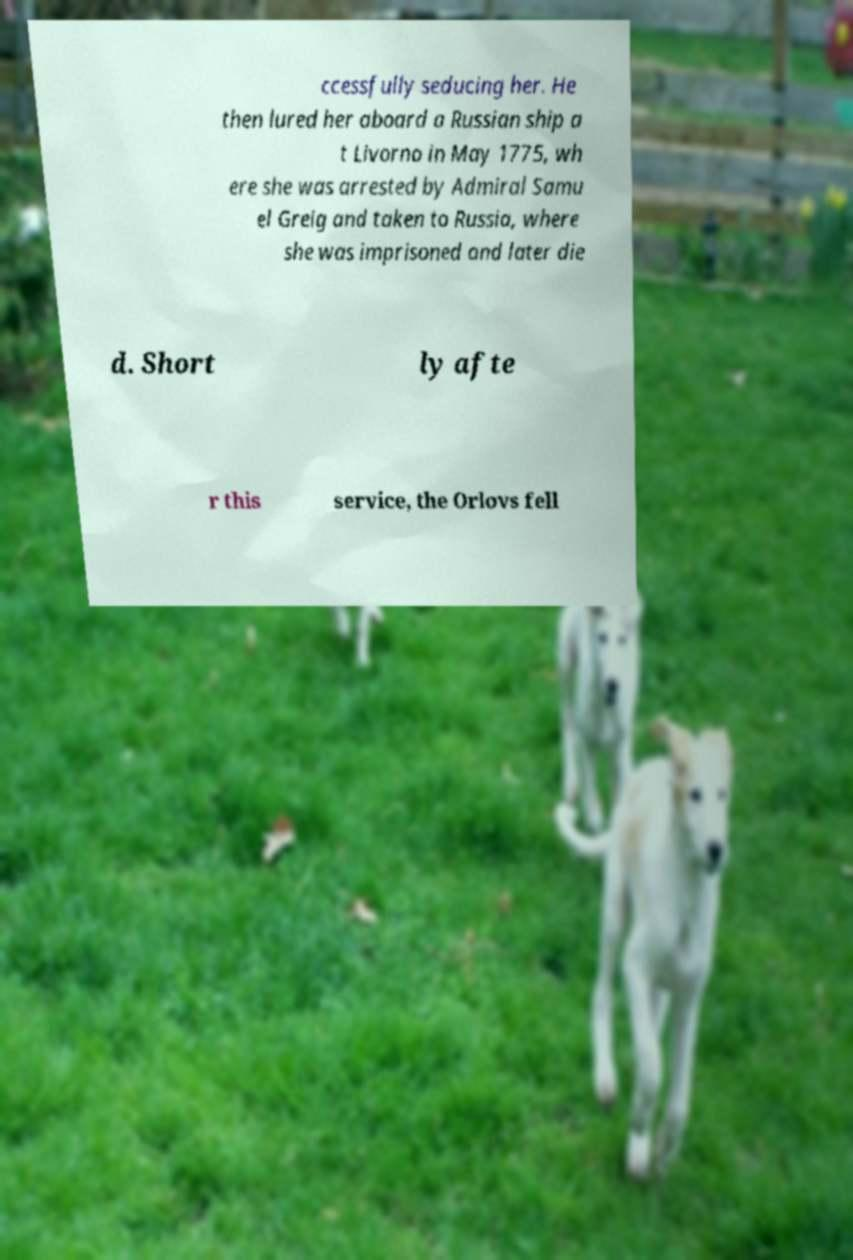Could you extract and type out the text from this image? ccessfully seducing her. He then lured her aboard a Russian ship a t Livorno in May 1775, wh ere she was arrested by Admiral Samu el Greig and taken to Russia, where she was imprisoned and later die d. Short ly afte r this service, the Orlovs fell 